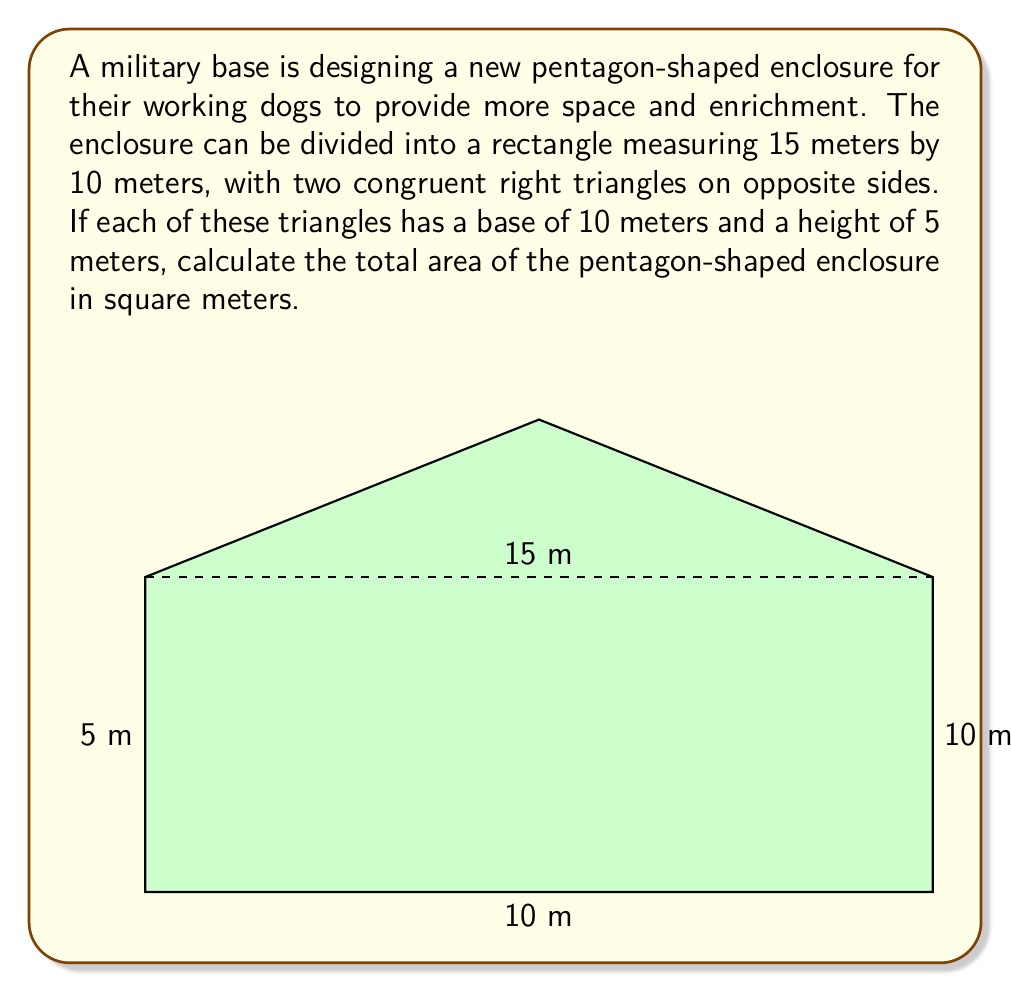Can you answer this question? To calculate the area of the pentagon-shaped enclosure, we'll break it down into three parts: one rectangle and two congruent right triangles. Let's solve this step-by-step:

1. Calculate the area of the rectangle:
   $A_{rectangle} = length \times width = 15 \text{ m} \times 10 \text{ m} = 150 \text{ m}^2$

2. Calculate the area of one right triangle:
   $A_{triangle} = \frac{1}{2} \times base \times height = \frac{1}{2} \times 10 \text{ m} \times 5 \text{ m} = 25 \text{ m}^2$

3. Since there are two congruent triangles, multiply the area of one triangle by 2:
   $A_{two triangles} = 2 \times 25 \text{ m}^2 = 50 \text{ m}^2$

4. Sum up the areas to get the total area of the pentagon:
   $A_{total} = A_{rectangle} + A_{two triangles} = 150 \text{ m}^2 + 50 \text{ m}^2 = 200 \text{ m}^2$

Therefore, the total area of the pentagon-shaped enclosure is 200 square meters.
Answer: 200 m² 